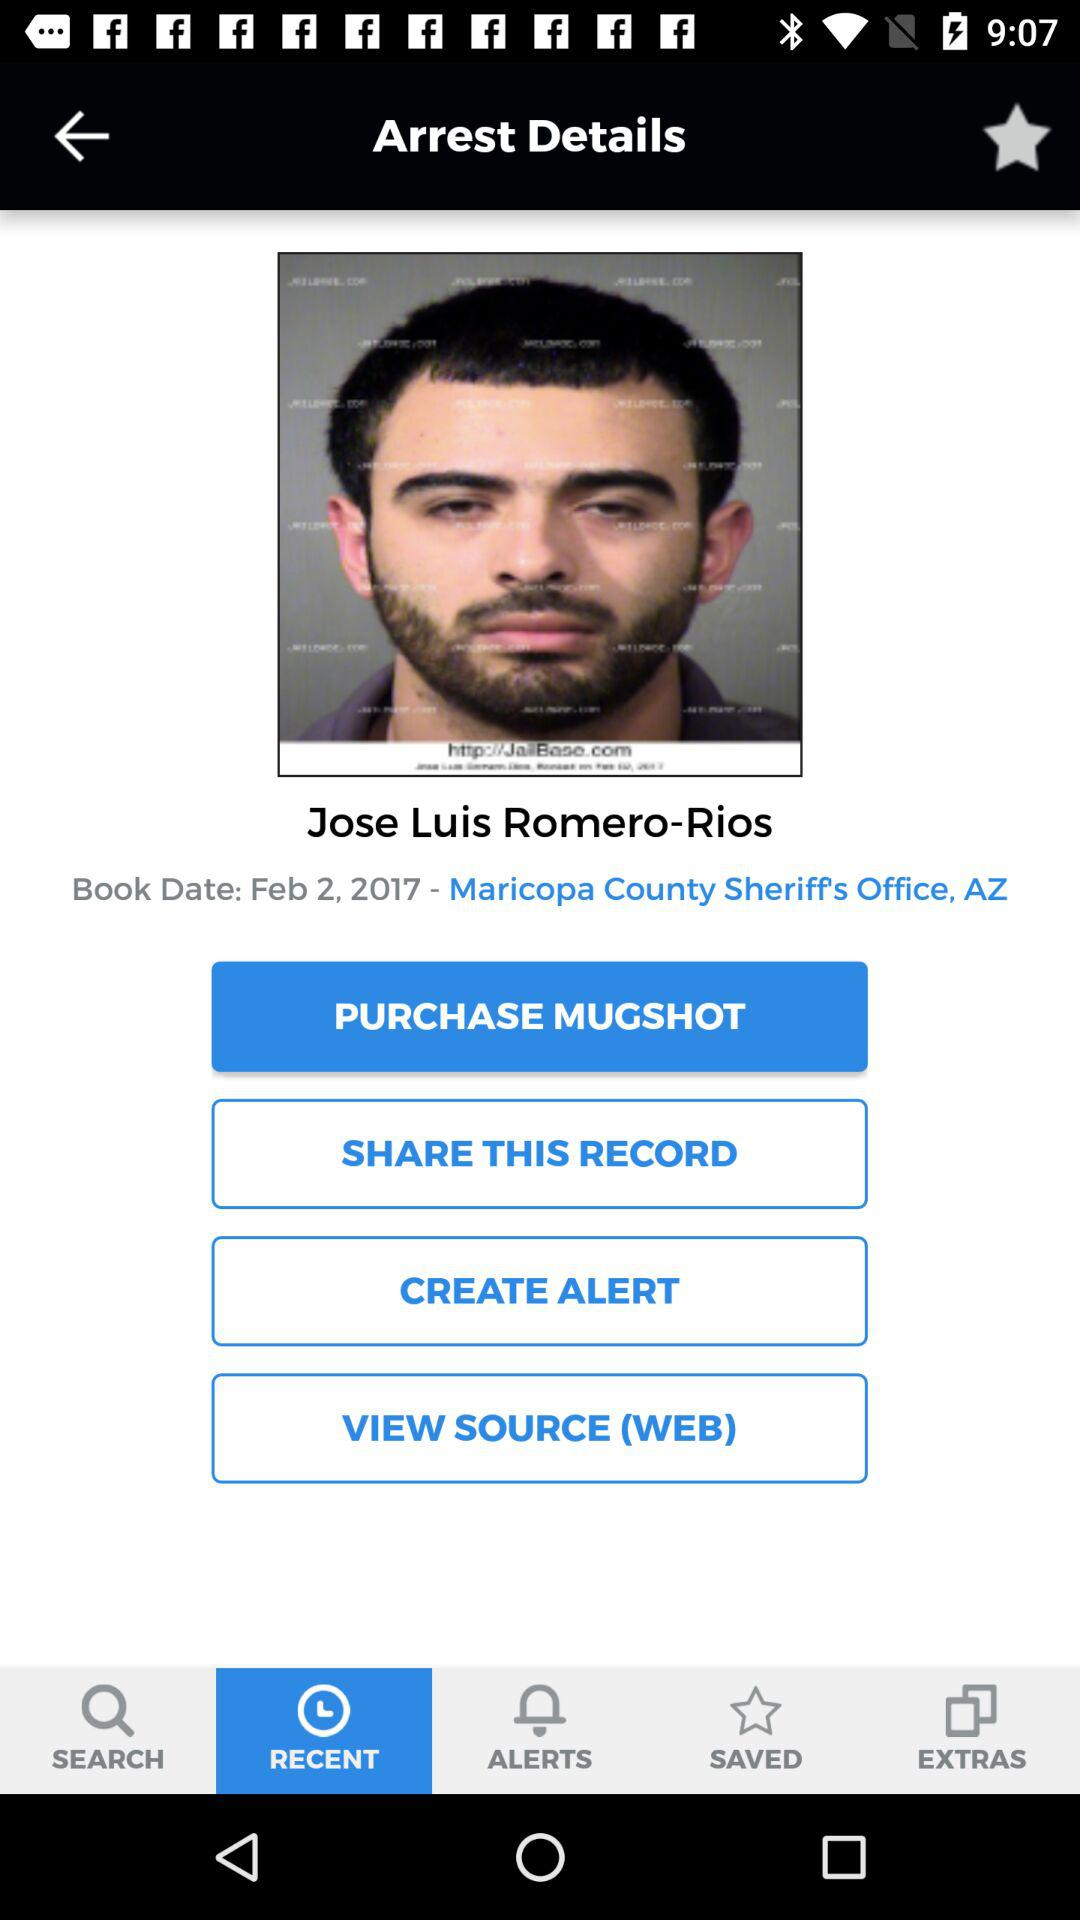What is the name of the person whose arrest details are being displayed?
Answer the question using a single word or phrase. Jose Luis Romero-Rios 